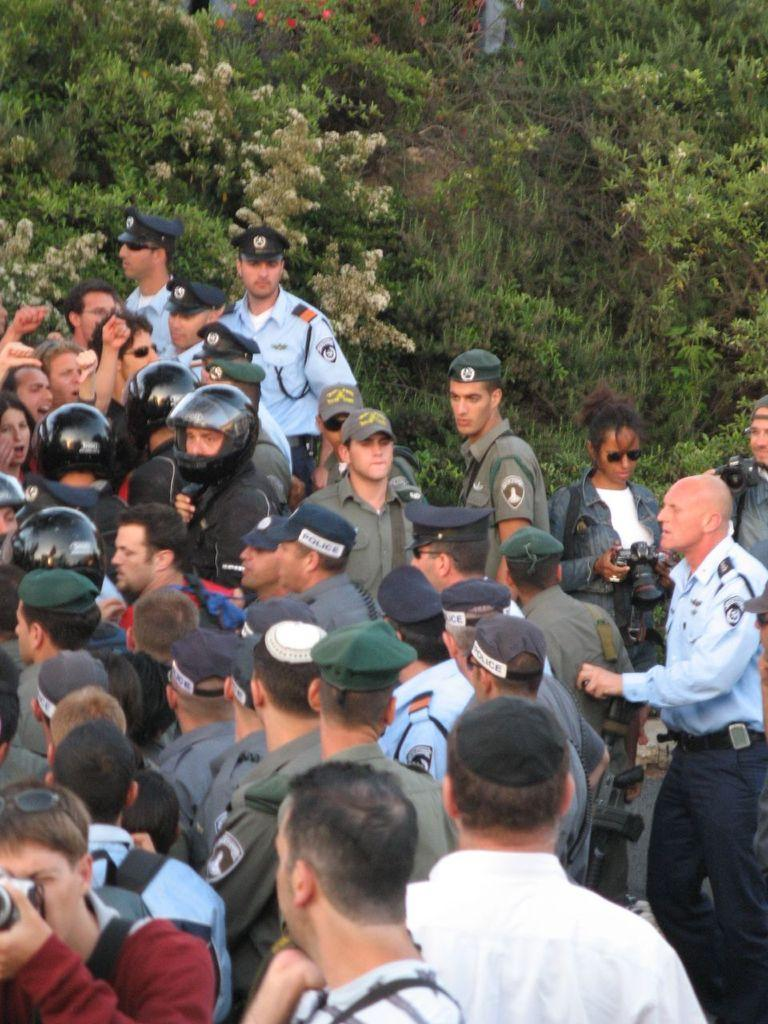How many people are in the group that is visible in the image? There is a group of people in the image, but the exact number is not specified. What are some people in the group wearing? Some people in the group are wearing caps. What are some people in the group holding? Some people in the group are holding cameras. What can be seen in the background of the image? There are plants and flowers in the background of the image. What type of wilderness can be seen in the background of the image? There is no wilderness present in the image; it features a group of people with plants and flowers in the background. Is there a battle taking place in the image? There is no battle present in the image; it features a group of people with cameras and caps. 